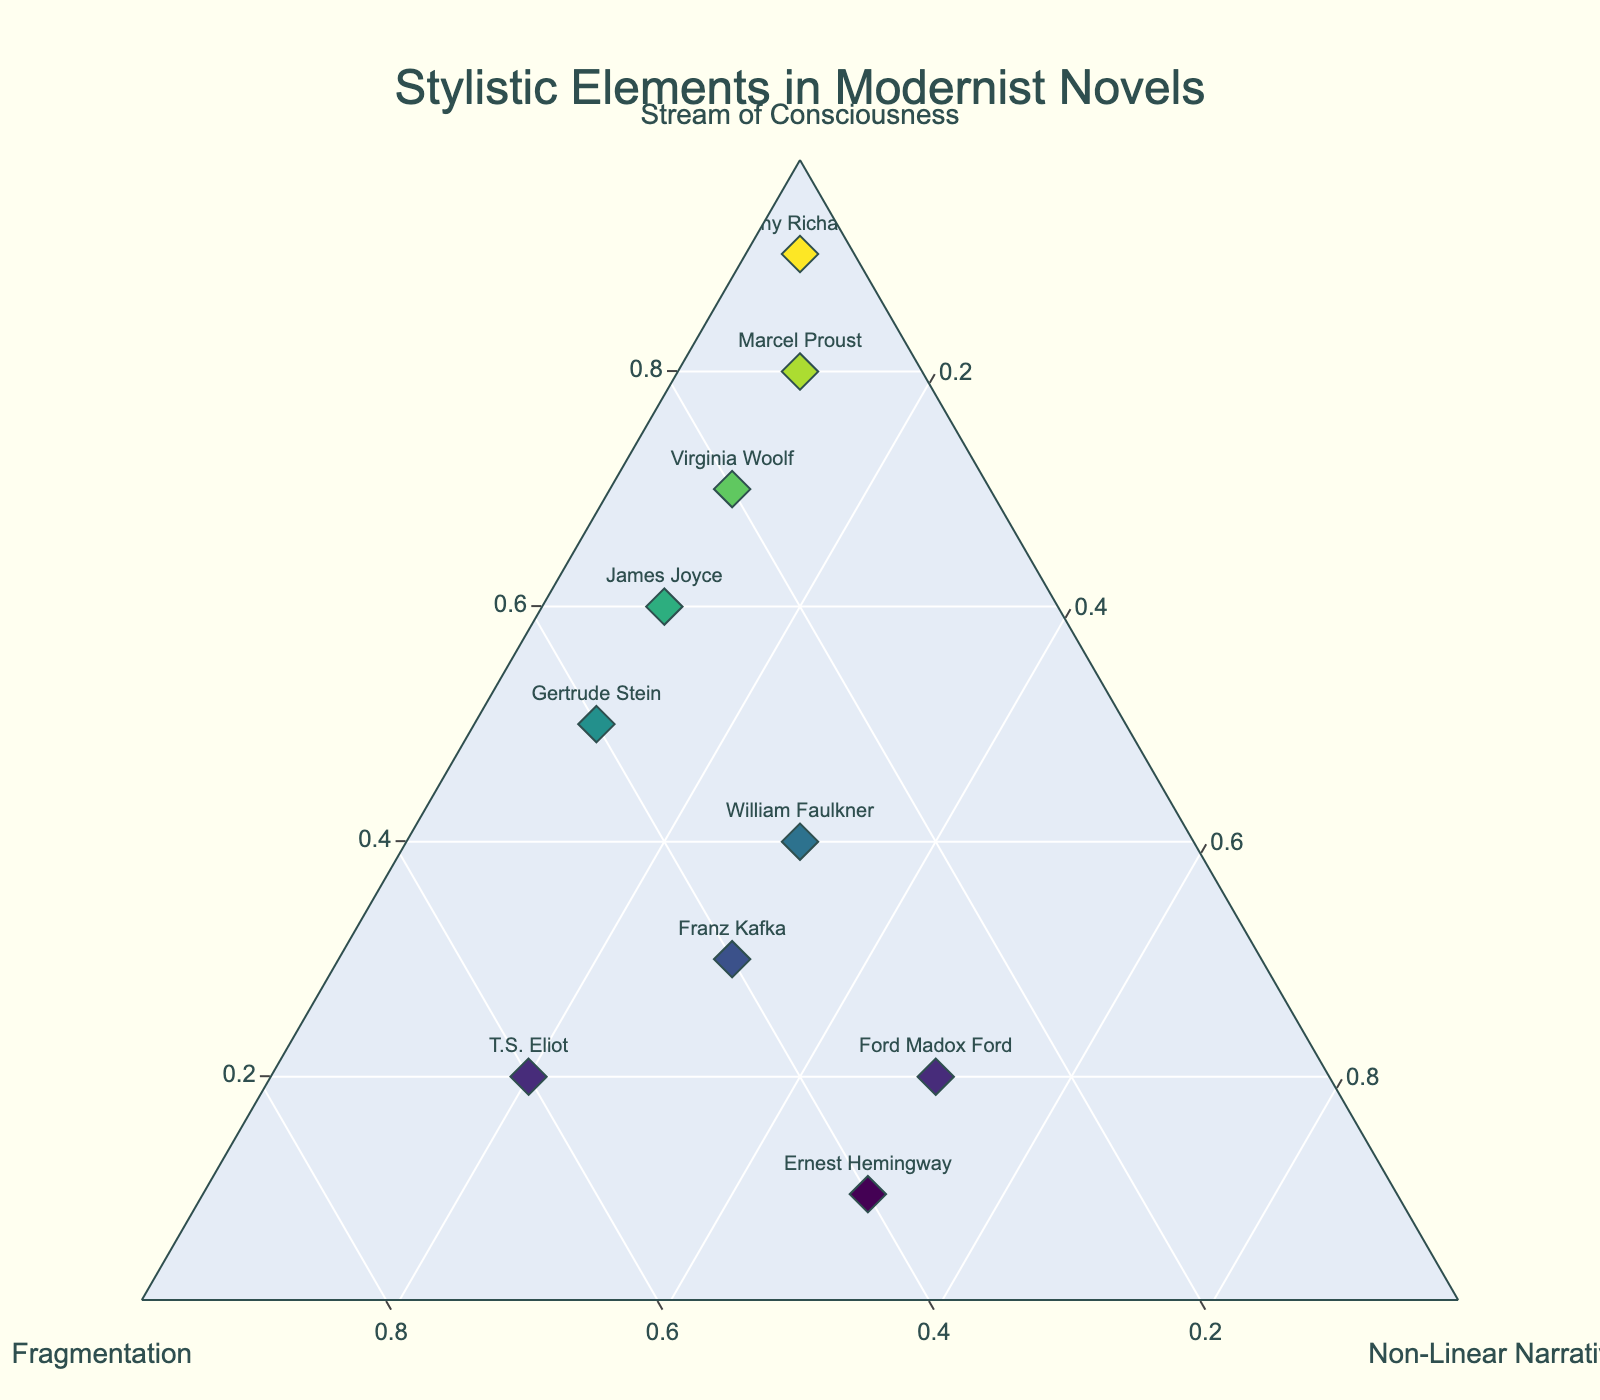What is the title of the figure? The title of the figure is usually placed at the top and center. According to the given code, the title is specified as "Stylistic Elements in Modernist Novels" and should appear prominently.
Answer: Stylistic Elements in Modernist Novels Which author has the highest value for 'Stream of Consciousness'? By looking at the points placed closest to the 'Stream of Consciousness' axis, Dorothy Richardson has the highest value at 0.9.
Answer: Dorothy Richardson How many authors have a Fragmentation value of 0.3? By identifying the points positioned close to 0.3 on the Fragmentation axis and counting the authors, we see that there are three authors: James Joyce, William Faulkner, and Ford Madox Ford.
Answer: 3 Which author has the most balanced distribution between the three stylistic elements? By assessing which author's point is closest to the center of the ternary plot, William Faulkner appears the most balanced because his values (0.4, 0.3, 0.3) are the closest to being equal.
Answer: William Faulkner Which author has the highest Non-Linear Narrative value? We look for the point closest to the 'Non-Linear Narrative' axis, which turns out to be Ernest Hemingway with a value of 0.5.
Answer: Ernest Hemingway What is the sum of values for Stream of Consciousness of Virginia Woolf and Marcel Proust? By adding the Stream of Consciousness values of the two authors, we calculate 0.7 (Virginia Woolf) + 0.8 (Marcel Proust) = 1.5.
Answer: 1.5 Which authors share a Stream of Consciousness value of 0.5 or higher? By listing authors whose Stream of Consciousness values >= 0.5, we find Virginia Woolf (0.7), James Joyce (0.6), Marcel Proust (0.8), and Dorothy Richardson (0.9).
Answer: Virginia Woolf, James Joyce, Marcel Proust, Dorothy Richardson Who has higher Fragmentation, T.S. Eliot or Franz Kafka? By directly comparing the Fragmentation values, T.S. Eliot (0.6) has a higher value compared to Franz Kafka (0.4).
Answer: T.S. Eliot Considering all authors with a Non-Linear Narrative value higher than 0.2, which one has the highest Stream of Consciousness value? Comparing authors with a Non-Linear Narrative value > 0.2 (William Faulkner, Ernest Hemingway, Franz Kafka, Ford Madox Ford), William Faulkner has the highest Stream of Consciousness value at 0.4.
Answer: William Faulkner What is the ratio between Stream of Consciousness and Fragmentation for Gertrude Stein? By dividing her Stream of Consciousness value (0.5) by her Fragmentation value (0.4), we get a ratio of 0.5/0.4 = 1.25.
Answer: 1.25 